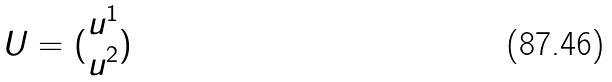<formula> <loc_0><loc_0><loc_500><loc_500>U = ( \begin{matrix} u ^ { 1 } \\ u ^ { 2 } \end{matrix} )</formula> 